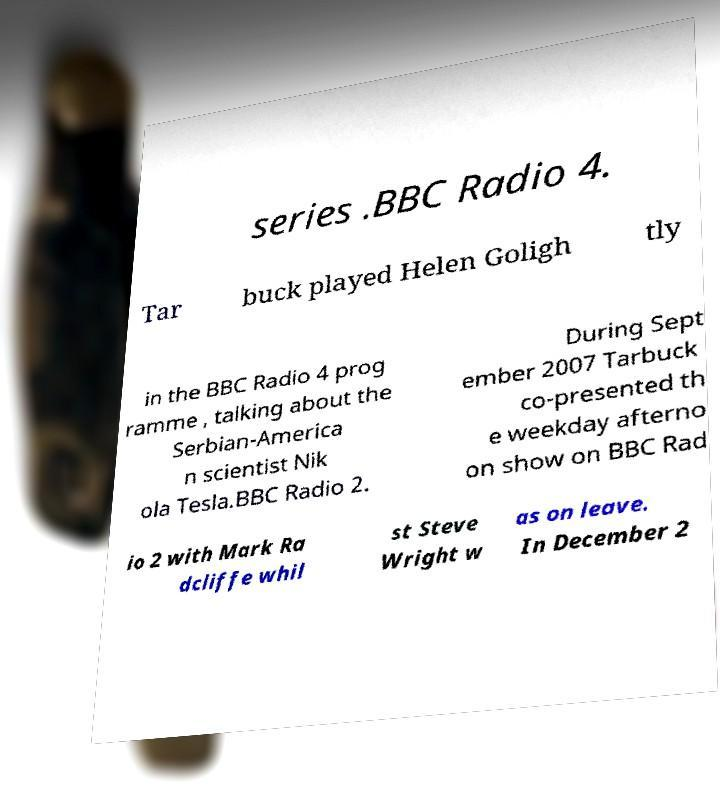Can you accurately transcribe the text from the provided image for me? series .BBC Radio 4. Tar buck played Helen Goligh tly in the BBC Radio 4 prog ramme , talking about the Serbian-America n scientist Nik ola Tesla.BBC Radio 2. During Sept ember 2007 Tarbuck co-presented th e weekday afterno on show on BBC Rad io 2 with Mark Ra dcliffe whil st Steve Wright w as on leave. In December 2 